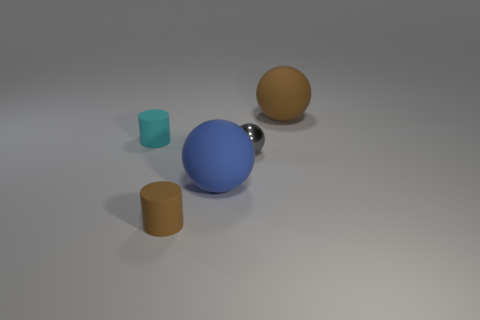How many other small gray spheres are the same material as the small sphere?
Give a very brief answer. 0. How many large balls are there?
Your response must be concise. 2. There is a small rubber cylinder that is in front of the small cyan thing on the left side of the brown object that is in front of the tiny gray thing; what color is it?
Provide a succinct answer. Brown. Do the brown sphere and the small object to the right of the small brown thing have the same material?
Offer a very short reply. No. What is the gray sphere made of?
Provide a succinct answer. Metal. How many other things are the same material as the tiny cyan cylinder?
Your answer should be very brief. 3. What shape is the tiny thing that is on the left side of the tiny metal ball and in front of the small cyan rubber object?
Make the answer very short. Cylinder. There is a big object that is made of the same material as the brown sphere; what is its color?
Ensure brevity in your answer.  Blue. Are there an equal number of tiny shiny balls left of the tiny shiny sphere and big purple metal cubes?
Ensure brevity in your answer.  Yes. What is the shape of the gray object that is the same size as the brown cylinder?
Offer a terse response. Sphere. 